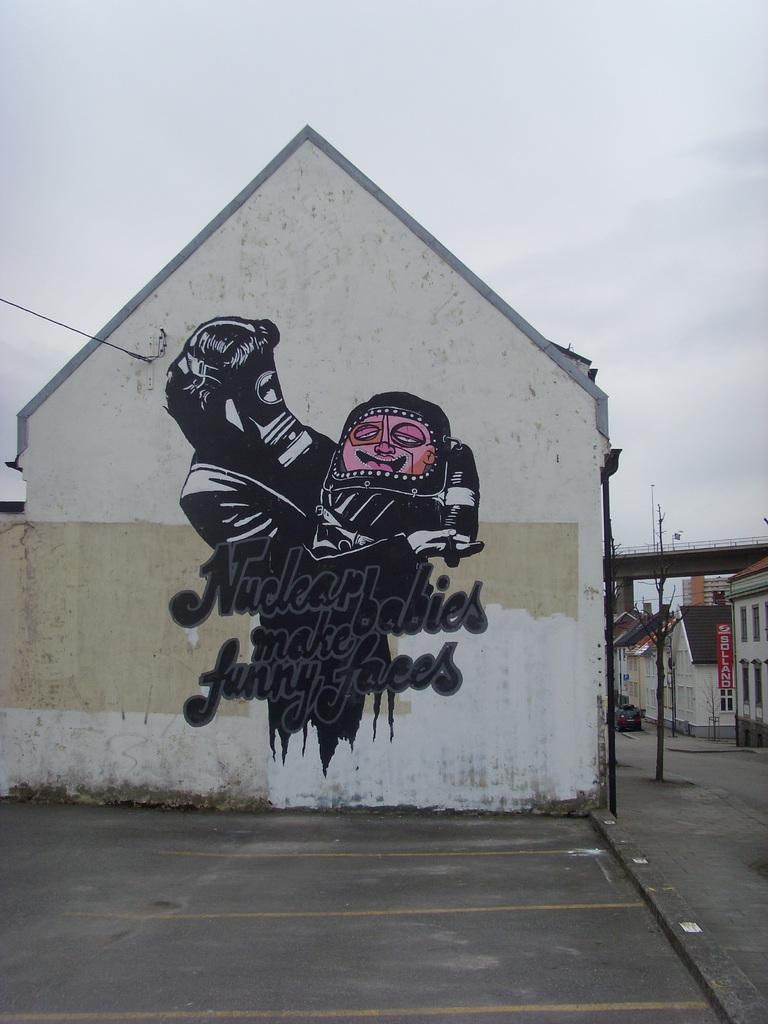Provide a one-sentence caption for the provided image. A painting on the side of a building depicts a person wearing a gas mask holding a deformed baby with the annotation "Nuclear babies make funny faces.". 